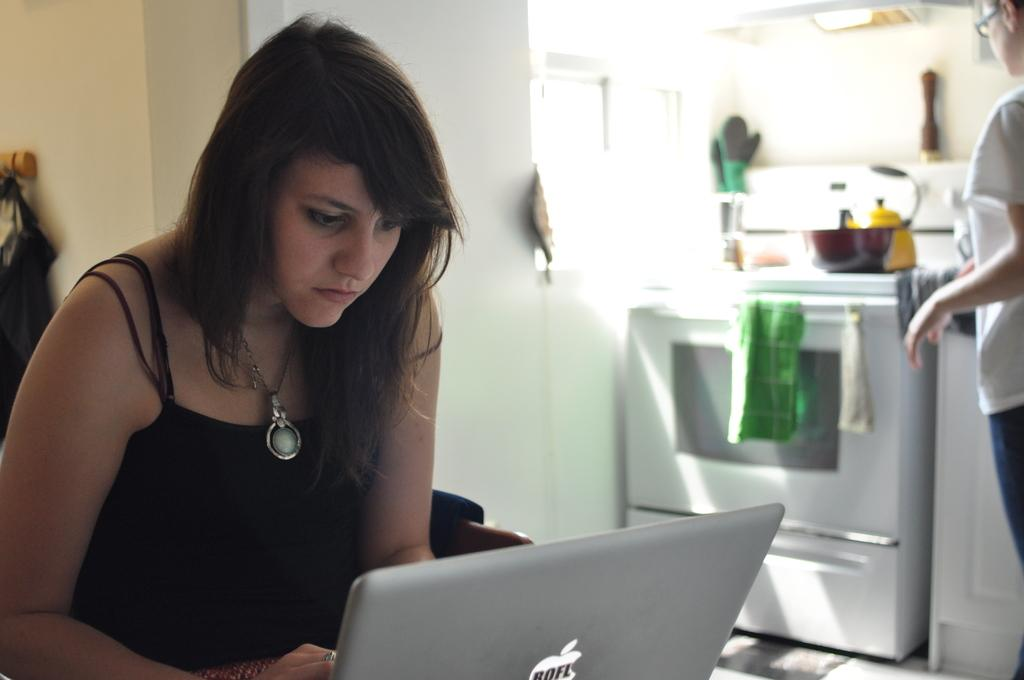Provide a one-sentence caption for the provided image. A women wearing a necklace is using an Apple laptop in a kitchen. 